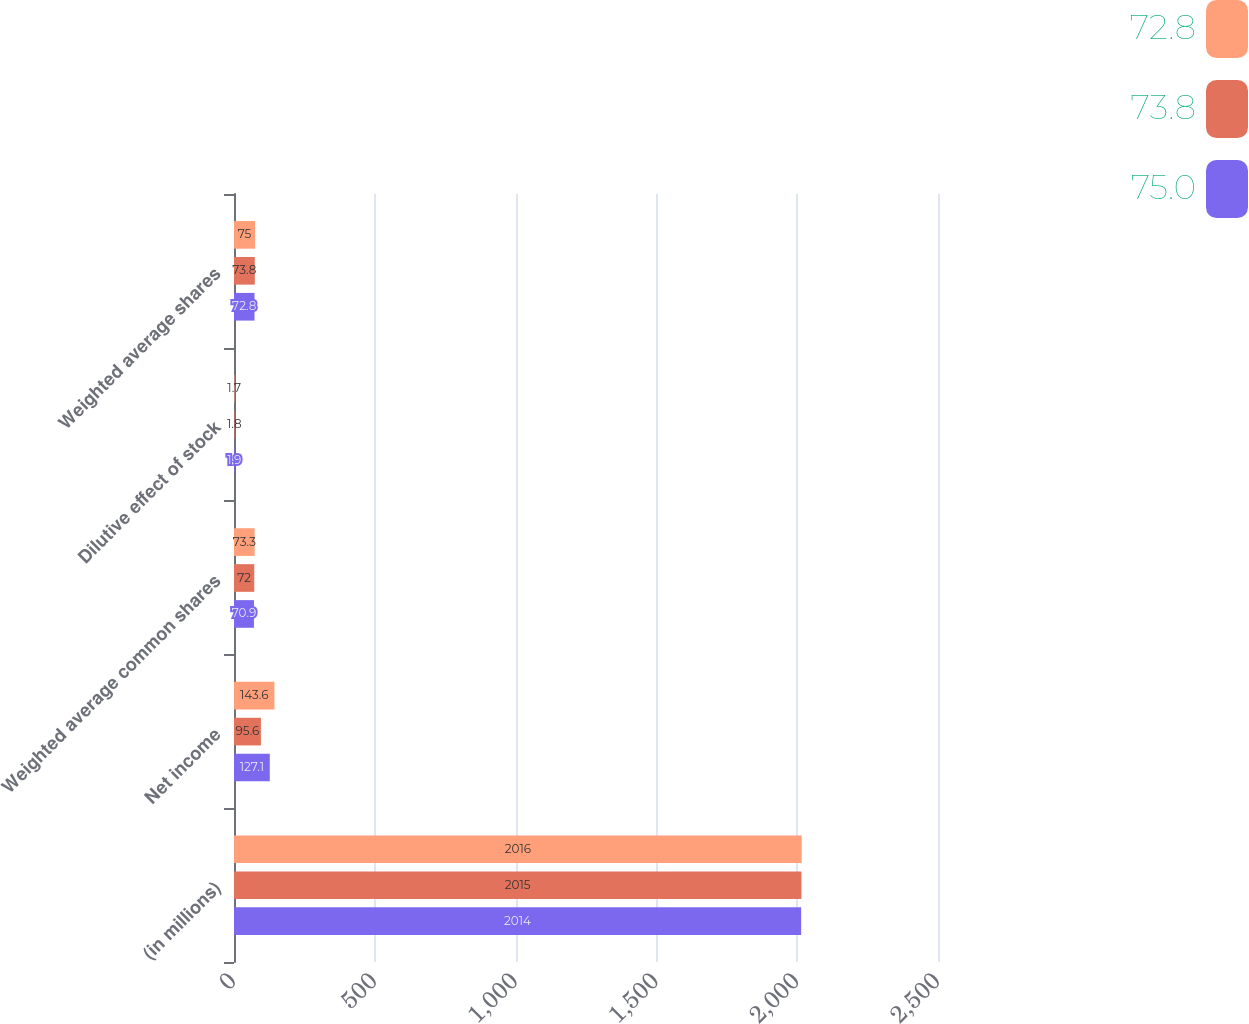Convert chart to OTSL. <chart><loc_0><loc_0><loc_500><loc_500><stacked_bar_chart><ecel><fcel>(in millions)<fcel>Net income<fcel>Weighted average common shares<fcel>Dilutive effect of stock<fcel>Weighted average shares<nl><fcel>72.8<fcel>2016<fcel>143.6<fcel>73.3<fcel>1.7<fcel>75<nl><fcel>73.8<fcel>2015<fcel>95.6<fcel>72<fcel>1.8<fcel>73.8<nl><fcel>75<fcel>2014<fcel>127.1<fcel>70.9<fcel>1.9<fcel>72.8<nl></chart> 